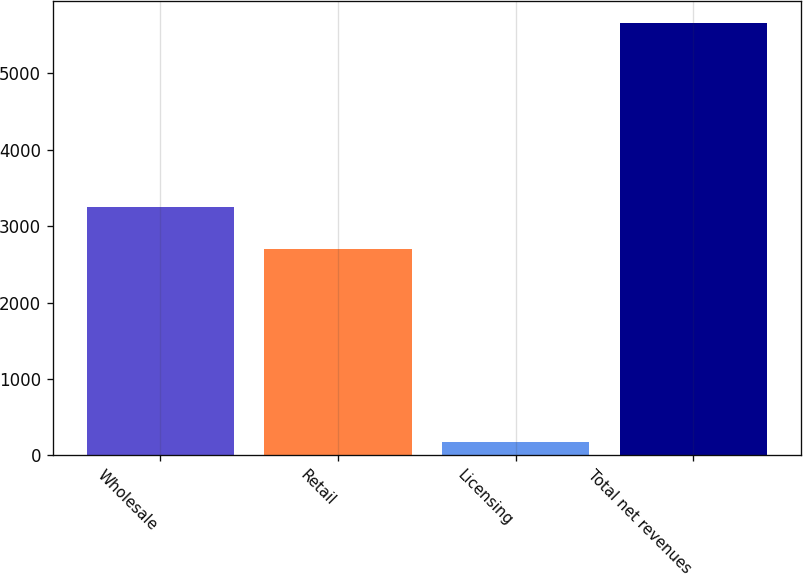Convert chart. <chart><loc_0><loc_0><loc_500><loc_500><bar_chart><fcel>Wholesale<fcel>Retail<fcel>Licensing<fcel>Total net revenues<nl><fcel>3252.38<fcel>2704.2<fcel>178.5<fcel>5660.3<nl></chart> 